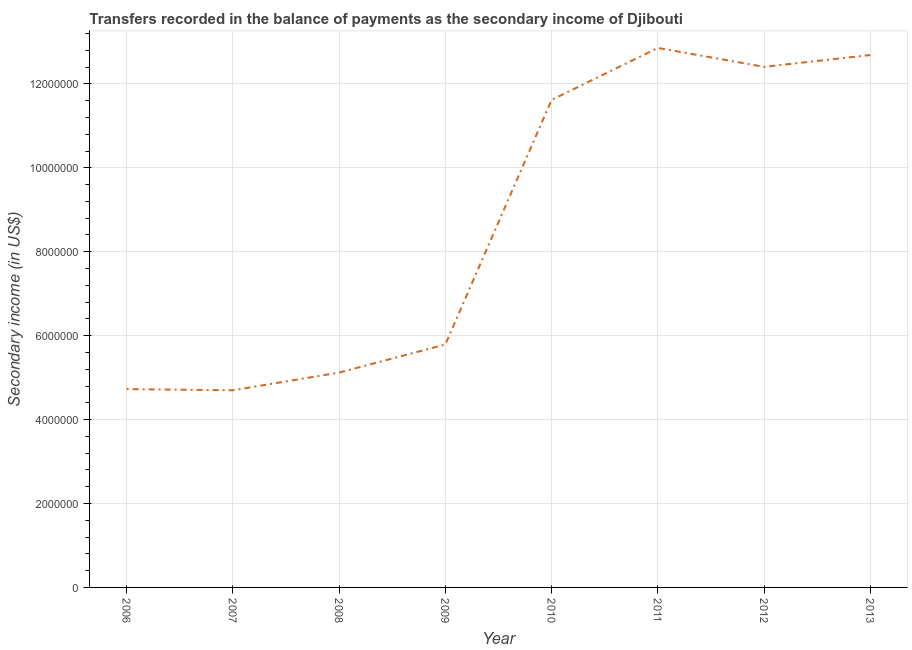What is the amount of secondary income in 2008?
Make the answer very short. 5.12e+06. Across all years, what is the maximum amount of secondary income?
Offer a very short reply. 1.29e+07. Across all years, what is the minimum amount of secondary income?
Make the answer very short. 4.70e+06. What is the sum of the amount of secondary income?
Make the answer very short. 6.99e+07. What is the difference between the amount of secondary income in 2008 and 2011?
Keep it short and to the point. -7.74e+06. What is the average amount of secondary income per year?
Make the answer very short. 8.74e+06. What is the median amount of secondary income?
Keep it short and to the point. 8.70e+06. In how many years, is the amount of secondary income greater than 9600000 US$?
Provide a short and direct response. 4. Do a majority of the years between 2012 and 2007 (inclusive) have amount of secondary income greater than 4400000 US$?
Make the answer very short. Yes. What is the ratio of the amount of secondary income in 2006 to that in 2012?
Make the answer very short. 0.38. Is the difference between the amount of secondary income in 2007 and 2013 greater than the difference between any two years?
Your response must be concise. No. What is the difference between the highest and the second highest amount of secondary income?
Keep it short and to the point. 1.69e+05. Is the sum of the amount of secondary income in 2007 and 2008 greater than the maximum amount of secondary income across all years?
Offer a terse response. No. What is the difference between the highest and the lowest amount of secondary income?
Provide a succinct answer. 8.16e+06. What is the difference between two consecutive major ticks on the Y-axis?
Provide a short and direct response. 2.00e+06. Does the graph contain any zero values?
Give a very brief answer. No. What is the title of the graph?
Provide a succinct answer. Transfers recorded in the balance of payments as the secondary income of Djibouti. What is the label or title of the Y-axis?
Ensure brevity in your answer.  Secondary income (in US$). What is the Secondary income (in US$) of 2006?
Ensure brevity in your answer.  4.73e+06. What is the Secondary income (in US$) of 2007?
Your response must be concise. 4.70e+06. What is the Secondary income (in US$) in 2008?
Give a very brief answer. 5.12e+06. What is the Secondary income (in US$) in 2009?
Provide a short and direct response. 5.79e+06. What is the Secondary income (in US$) in 2010?
Make the answer very short. 1.16e+07. What is the Secondary income (in US$) in 2011?
Your answer should be very brief. 1.29e+07. What is the Secondary income (in US$) in 2012?
Make the answer very short. 1.24e+07. What is the Secondary income (in US$) of 2013?
Offer a very short reply. 1.27e+07. What is the difference between the Secondary income (in US$) in 2006 and 2007?
Ensure brevity in your answer.  2.81e+04. What is the difference between the Secondary income (in US$) in 2006 and 2008?
Your answer should be very brief. -3.94e+05. What is the difference between the Secondary income (in US$) in 2006 and 2009?
Make the answer very short. -1.06e+06. What is the difference between the Secondary income (in US$) in 2006 and 2010?
Give a very brief answer. -6.89e+06. What is the difference between the Secondary income (in US$) in 2006 and 2011?
Your answer should be compact. -8.13e+06. What is the difference between the Secondary income (in US$) in 2006 and 2012?
Give a very brief answer. -7.68e+06. What is the difference between the Secondary income (in US$) in 2006 and 2013?
Your response must be concise. -7.96e+06. What is the difference between the Secondary income (in US$) in 2007 and 2008?
Keep it short and to the point. -4.22e+05. What is the difference between the Secondary income (in US$) in 2007 and 2009?
Offer a terse response. -1.09e+06. What is the difference between the Secondary income (in US$) in 2007 and 2010?
Your answer should be very brief. -6.92e+06. What is the difference between the Secondary income (in US$) in 2007 and 2011?
Your answer should be very brief. -8.16e+06. What is the difference between the Secondary income (in US$) in 2007 and 2012?
Your response must be concise. -7.71e+06. What is the difference between the Secondary income (in US$) in 2007 and 2013?
Provide a succinct answer. -7.99e+06. What is the difference between the Secondary income (in US$) in 2008 and 2009?
Keep it short and to the point. -6.70e+05. What is the difference between the Secondary income (in US$) in 2008 and 2010?
Your answer should be very brief. -6.50e+06. What is the difference between the Secondary income (in US$) in 2008 and 2011?
Offer a terse response. -7.74e+06. What is the difference between the Secondary income (in US$) in 2008 and 2012?
Make the answer very short. -7.29e+06. What is the difference between the Secondary income (in US$) in 2008 and 2013?
Ensure brevity in your answer.  -7.57e+06. What is the difference between the Secondary income (in US$) in 2009 and 2010?
Give a very brief answer. -5.83e+06. What is the difference between the Secondary income (in US$) in 2009 and 2011?
Your response must be concise. -7.07e+06. What is the difference between the Secondary income (in US$) in 2009 and 2012?
Offer a terse response. -6.62e+06. What is the difference between the Secondary income (in US$) in 2009 and 2013?
Your answer should be very brief. -6.90e+06. What is the difference between the Secondary income (in US$) in 2010 and 2011?
Make the answer very short. -1.24e+06. What is the difference between the Secondary income (in US$) in 2010 and 2012?
Offer a very short reply. -7.88e+05. What is the difference between the Secondary income (in US$) in 2010 and 2013?
Offer a terse response. -1.07e+06. What is the difference between the Secondary income (in US$) in 2011 and 2012?
Keep it short and to the point. 4.50e+05. What is the difference between the Secondary income (in US$) in 2011 and 2013?
Offer a terse response. 1.69e+05. What is the difference between the Secondary income (in US$) in 2012 and 2013?
Provide a succinct answer. -2.81e+05. What is the ratio of the Secondary income (in US$) in 2006 to that in 2007?
Provide a succinct answer. 1.01. What is the ratio of the Secondary income (in US$) in 2006 to that in 2008?
Ensure brevity in your answer.  0.92. What is the ratio of the Secondary income (in US$) in 2006 to that in 2009?
Ensure brevity in your answer.  0.82. What is the ratio of the Secondary income (in US$) in 2006 to that in 2010?
Your answer should be very brief. 0.41. What is the ratio of the Secondary income (in US$) in 2006 to that in 2011?
Ensure brevity in your answer.  0.37. What is the ratio of the Secondary income (in US$) in 2006 to that in 2012?
Your answer should be compact. 0.38. What is the ratio of the Secondary income (in US$) in 2006 to that in 2013?
Keep it short and to the point. 0.37. What is the ratio of the Secondary income (in US$) in 2007 to that in 2008?
Give a very brief answer. 0.92. What is the ratio of the Secondary income (in US$) in 2007 to that in 2009?
Keep it short and to the point. 0.81. What is the ratio of the Secondary income (in US$) in 2007 to that in 2010?
Provide a succinct answer. 0.4. What is the ratio of the Secondary income (in US$) in 2007 to that in 2011?
Give a very brief answer. 0.36. What is the ratio of the Secondary income (in US$) in 2007 to that in 2012?
Provide a succinct answer. 0.38. What is the ratio of the Secondary income (in US$) in 2007 to that in 2013?
Offer a very short reply. 0.37. What is the ratio of the Secondary income (in US$) in 2008 to that in 2009?
Your response must be concise. 0.88. What is the ratio of the Secondary income (in US$) in 2008 to that in 2010?
Ensure brevity in your answer.  0.44. What is the ratio of the Secondary income (in US$) in 2008 to that in 2011?
Provide a succinct answer. 0.4. What is the ratio of the Secondary income (in US$) in 2008 to that in 2012?
Provide a short and direct response. 0.41. What is the ratio of the Secondary income (in US$) in 2008 to that in 2013?
Give a very brief answer. 0.4. What is the ratio of the Secondary income (in US$) in 2009 to that in 2010?
Ensure brevity in your answer.  0.5. What is the ratio of the Secondary income (in US$) in 2009 to that in 2011?
Offer a very short reply. 0.45. What is the ratio of the Secondary income (in US$) in 2009 to that in 2012?
Offer a very short reply. 0.47. What is the ratio of the Secondary income (in US$) in 2009 to that in 2013?
Give a very brief answer. 0.46. What is the ratio of the Secondary income (in US$) in 2010 to that in 2011?
Give a very brief answer. 0.9. What is the ratio of the Secondary income (in US$) in 2010 to that in 2012?
Offer a terse response. 0.94. What is the ratio of the Secondary income (in US$) in 2010 to that in 2013?
Make the answer very short. 0.92. What is the ratio of the Secondary income (in US$) in 2011 to that in 2012?
Ensure brevity in your answer.  1.04. What is the ratio of the Secondary income (in US$) in 2011 to that in 2013?
Provide a succinct answer. 1.01. 